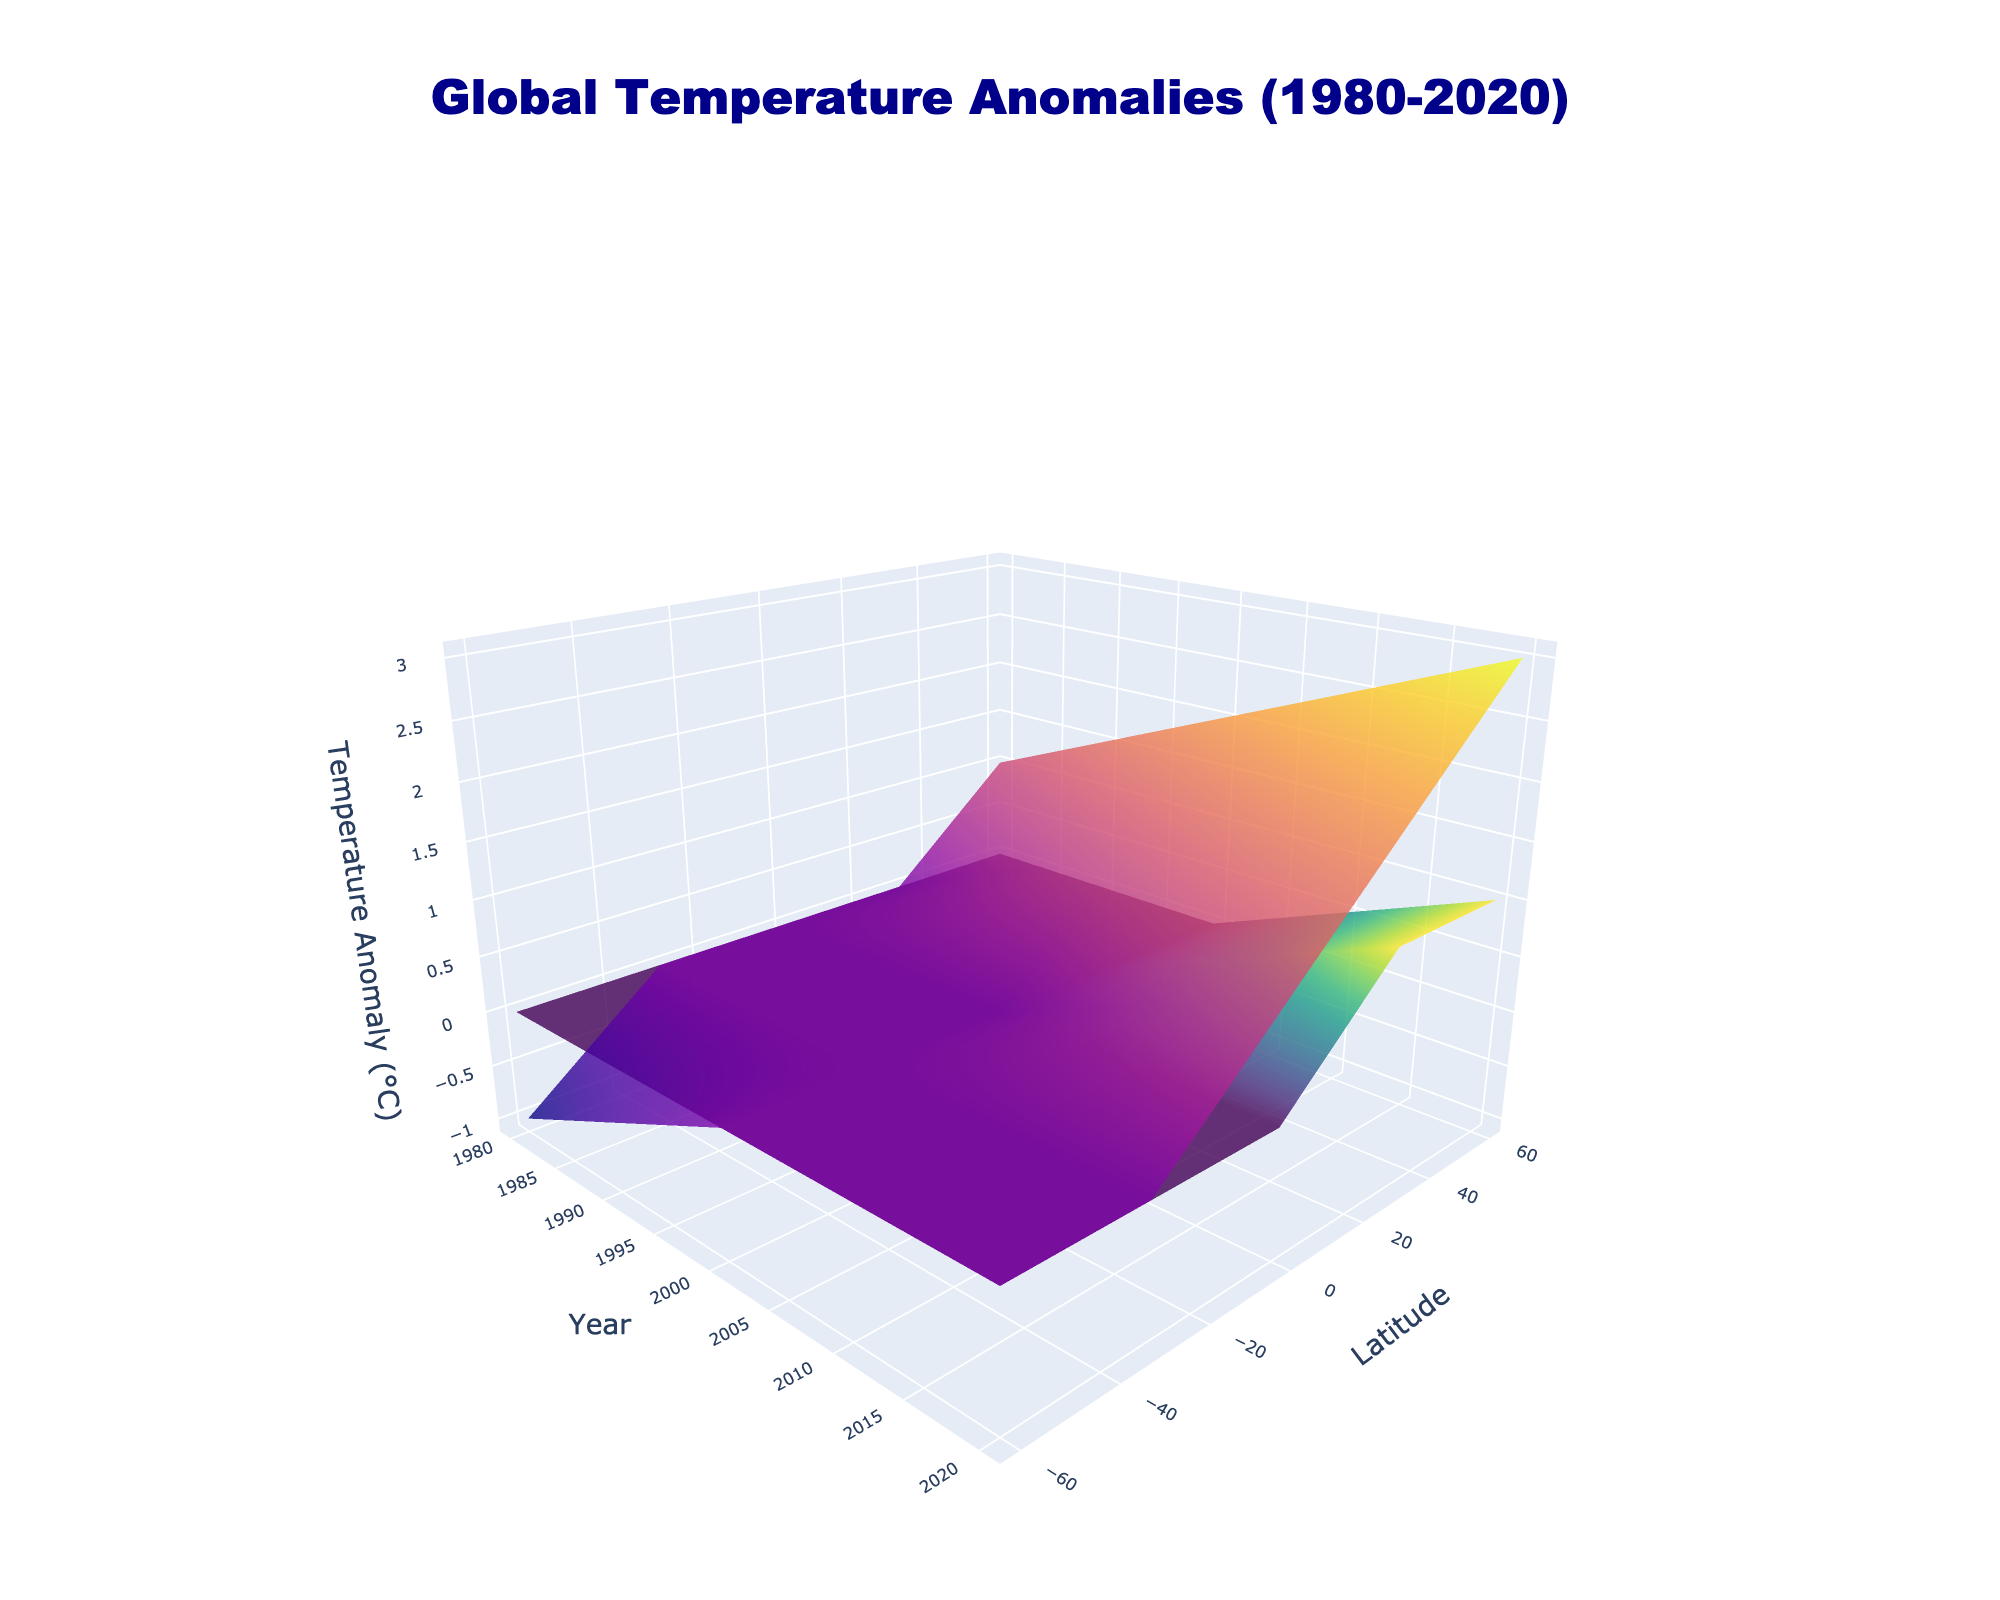what is the overall trend in temperature anomaly over the years for latitude 60 in July? The plot shows a 3D surface with the temperature anomaly on the z-axis, the year on the x-axis, and latitude on the y-axis. For latitude 60 in July, which should be represented by the Plasma colorscale trace, the temperature anomaly increases as you move from left (1980) to right (2020) on the x-axis. This indicates an upward trend.
Answer: Upward Which month (January or July) shows a higher temperature anomaly at latitude 0 in the year 2020? At year 2020 and latitude 0, we need to compare the surfaces representing January and July. The plot suggests that the July surface (Plasma colorscale) has a temperature anomaly of 1.2°C, while the January surface (Viridis colorscale) has a temperature anomaly of 0.6°C.
Answer: July What is the biggest temperature anomaly observed in July for any latitude across all the years? By observing the highest point on the July surface (Plasma colorscale), we see that the maximum temperature anomaly occurs at latitude 60 for the year 2020, reaching 3.0°C.
Answer: 3.0°C Compare the temperature anomaly at latitude -60 between January and July in the year 1980. For the year 1980 and latitude -60, the January surface shows a temperature anomaly of -0.3°C, and the July surface shows an anomaly of -1.0°C. Comparing these values, January has a higher temperature anomaly.
Answer: January How does the temperature anomaly difference between January and July at latitude 30 change from 1980 to 2020? For latitude 30:
- In 1980: January anomaly is 0.1°C, July anomaly is 0.8°C.
- In 2020: January anomaly is 1.0°C, July anomaly is 2.2°C.
The difference in 1980 is 0.8 - 0.1 = 0.7°C, and in 2020, it is 2.2 - 1.0 = 1.2°C, showing an increase in the anomaly difference over the years.
Answer: Increases What is the temperature anomaly change in January from the year 1980 to 2020 at latitude -30? For January at latitude -30:
- In 1980, the temperature anomaly is -0.2°C.
- In 2020, the temperature anomaly is 0.3°C.
The change is 0.3°C - (-0.2°C) = 0.5°C.
Answer: 0.5°C Which latitude exhibits the least temperature anomaly change in January from the year 1980 to 2020? We need to calculate the anomaly change for each latitude in January from 1980 to 2020:
- 60: 1.5°C - 0.2°C = 1.3°C
- 30: 1.0°C - 0.1°C = 0.9°C
- 0: 0.6°C - (-0.1°C) = 0.7°C
- -30: 0.3°C - (-0.2°C) = 0.5°C
- -60: 0.2°C - (-0.3°C) = 0.5°C
Latitudes -30 and -60 exhibit the least change, both with 0.5°C.
Answer: -30 and -60 What general pattern regarding temperature anomalies can be observed for different latitudes in July as years progress? By examining the July surface (Plasma colorscale), we see that the temperature anomalies increase for higher latitudes (>0) and decrease for lower latitudes (<0) as the years progress. This indicates a stronger warming trend at positive latitudes compared to negative latitudes in July.
Answer: Higher latitudes warm more 